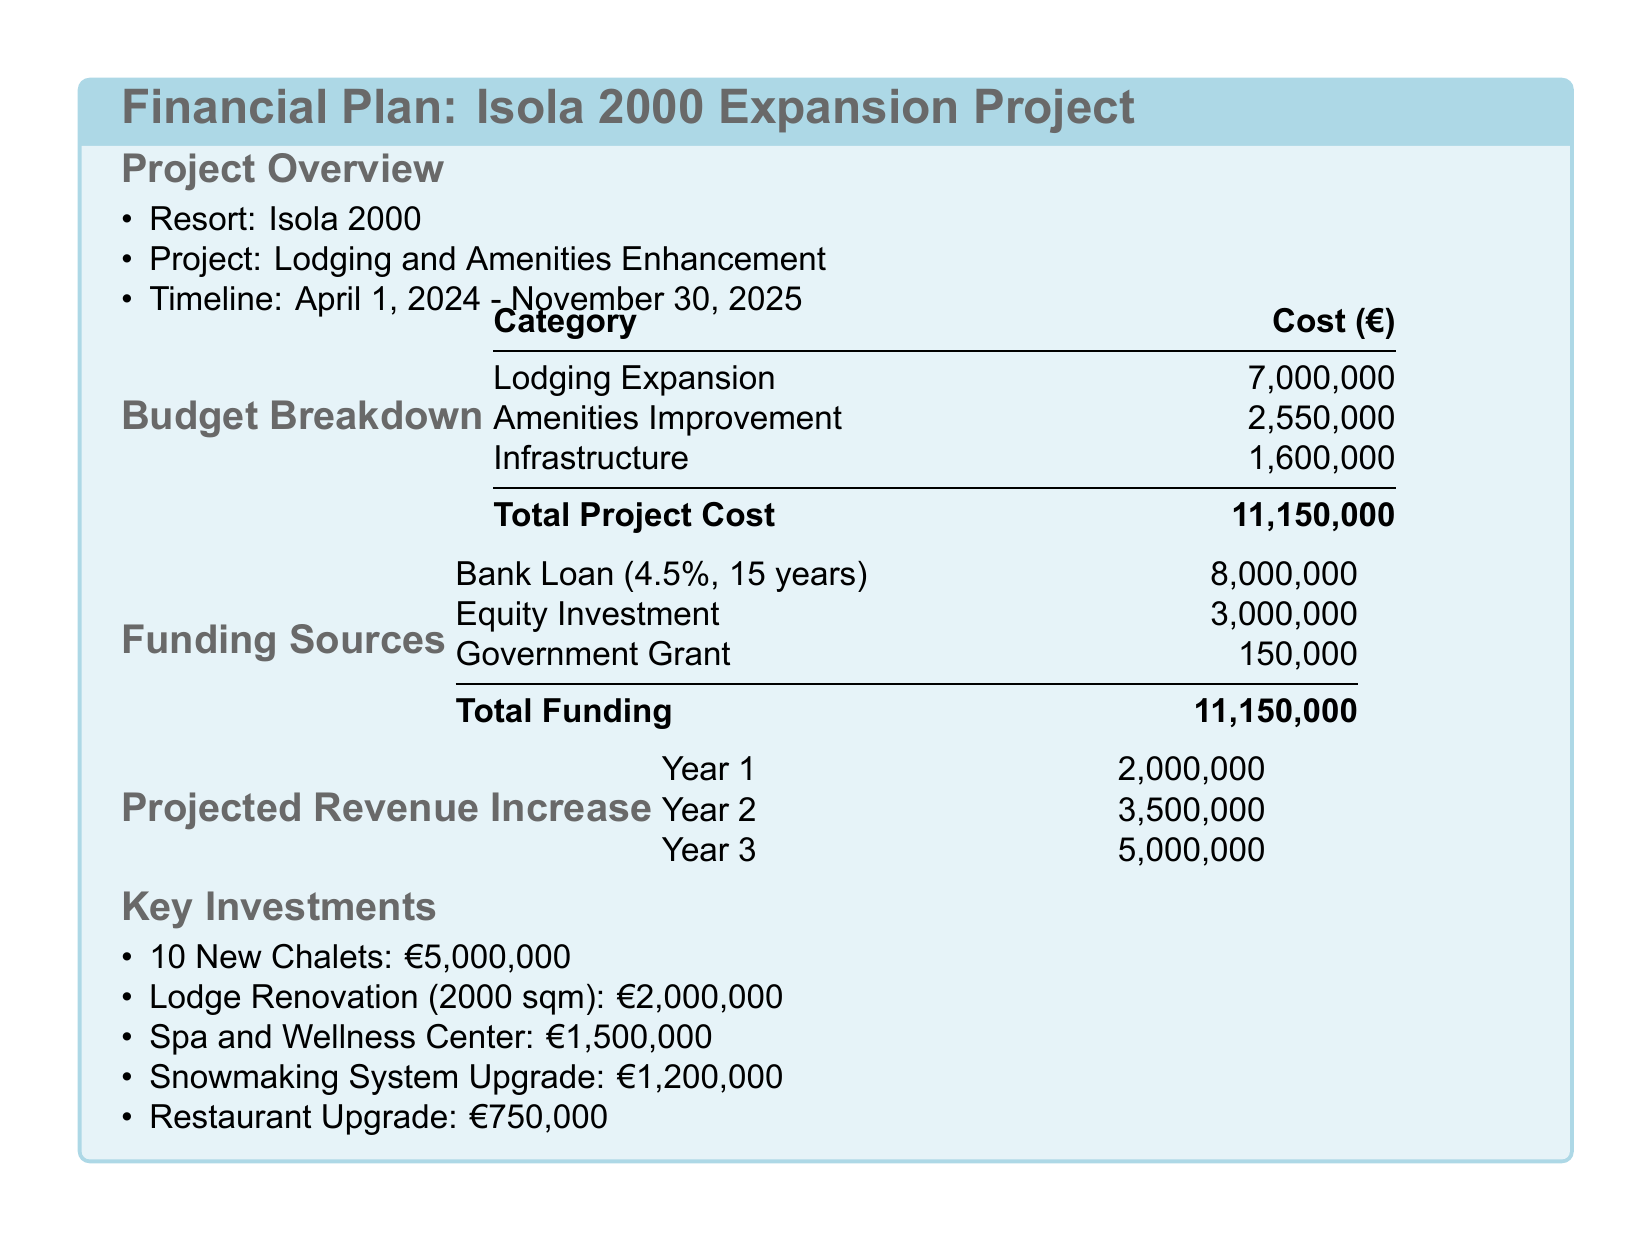What is the total project cost? The total project cost is the sum of all budget categories listed in the document.
Answer: 11,150,000 What is the funding source for the majority of the budget? The majority of the budget is funded through a bank loan.
Answer: Bank Loan How much is allocated for lodging expansion? The lodging expansion cost is specified in the budget breakdown section of the document.
Answer: 7,000,000 When does the project start? The project start date is clearly mentioned in the project overview section of the document.
Answer: April 1, 2024 What is the projected revenue for Year 2? The projected revenue for Year 2 is listed in the projected revenue increase table.
Answer: 3,500,000 How many new chalets are planned? The number of new chalets is explicitly stated in the key investments section.
Answer: 10 What is the cost of the Spa and Wellness Center? The cost for the Spa and Wellness Center is detailed in the key investments list.
Answer: 1,500,000 What percentage is the bank loan interest rate? The interest rate for the bank loan is provided in the funding sources table.
Answer: 4.5% What is the total funding amount? The total funding amount is the sum of all funding sources indicated in the document.
Answer: 11,150,000 